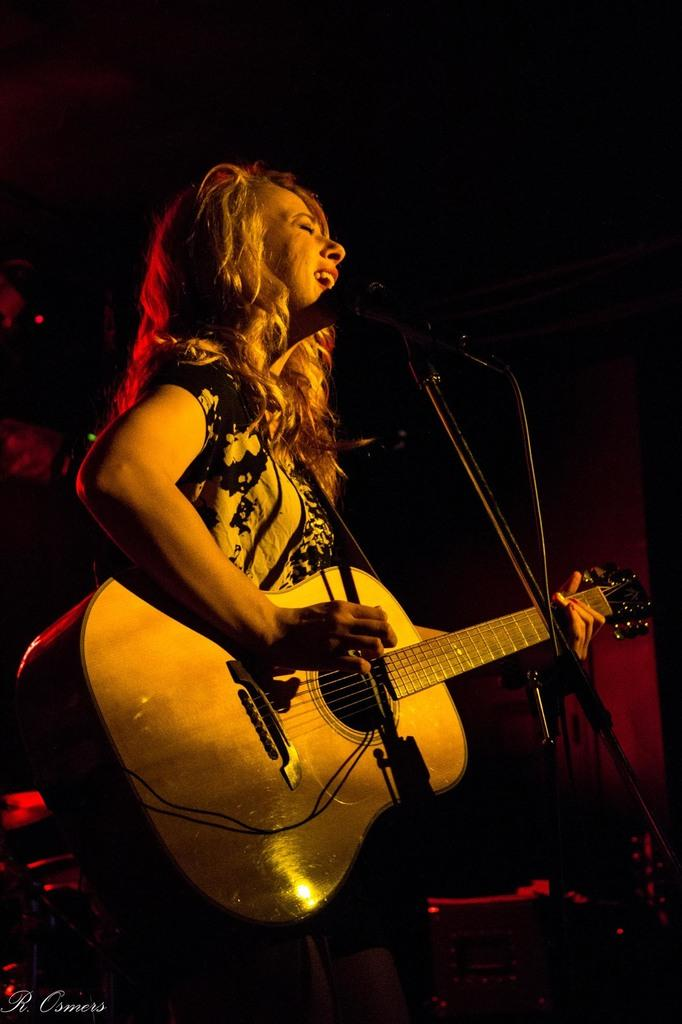Who is the main subject in the image? There is a woman in the image. What is the woman doing in the image? The woman is standing in front of a microphone and playing a guitar. How many children are visible in the image? There are no children present in the image. What type of writing instrument is the woman holding in the image? The woman is not holding a quill or any writing instrument in the image; she is playing a guitar. 